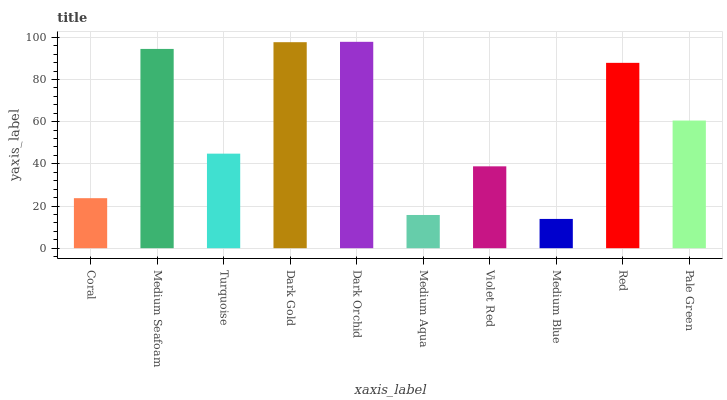Is Medium Blue the minimum?
Answer yes or no. Yes. Is Dark Orchid the maximum?
Answer yes or no. Yes. Is Medium Seafoam the minimum?
Answer yes or no. No. Is Medium Seafoam the maximum?
Answer yes or no. No. Is Medium Seafoam greater than Coral?
Answer yes or no. Yes. Is Coral less than Medium Seafoam?
Answer yes or no. Yes. Is Coral greater than Medium Seafoam?
Answer yes or no. No. Is Medium Seafoam less than Coral?
Answer yes or no. No. Is Pale Green the high median?
Answer yes or no. Yes. Is Turquoise the low median?
Answer yes or no. Yes. Is Dark Gold the high median?
Answer yes or no. No. Is Medium Blue the low median?
Answer yes or no. No. 